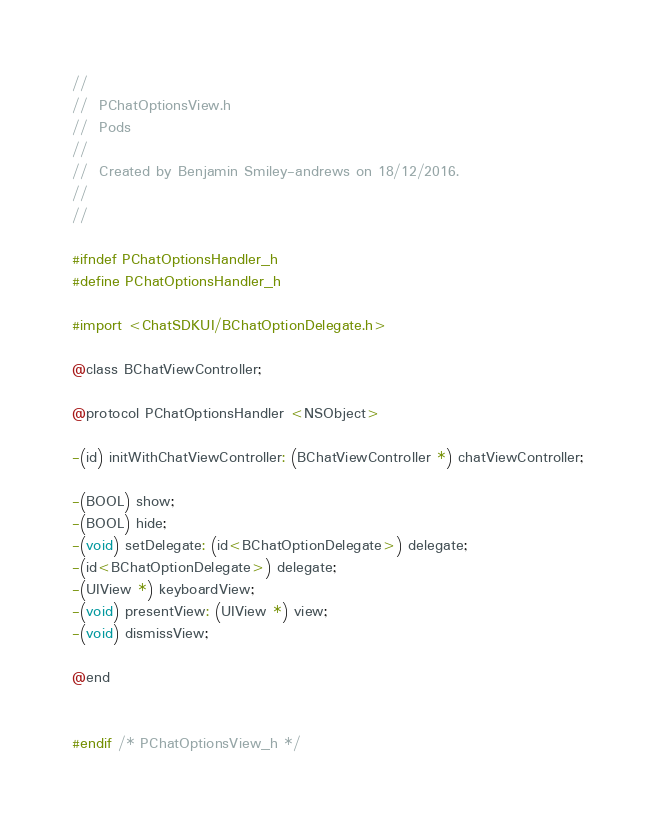Convert code to text. <code><loc_0><loc_0><loc_500><loc_500><_C_>//
//  PChatOptionsView.h
//  Pods
//
//  Created by Benjamin Smiley-andrews on 18/12/2016.
//
//

#ifndef PChatOptionsHandler_h
#define PChatOptionsHandler_h

#import <ChatSDKUI/BChatOptionDelegate.h>

@class BChatViewController;

@protocol PChatOptionsHandler <NSObject>

-(id) initWithChatViewController: (BChatViewController *) chatViewController;

-(BOOL) show;
-(BOOL) hide;
-(void) setDelegate: (id<BChatOptionDelegate>) delegate;
-(id<BChatOptionDelegate>) delegate;
-(UIView *) keyboardView;
-(void) presentView: (UIView *) view;
-(void) dismissView;

@end


#endif /* PChatOptionsView_h */
</code> 